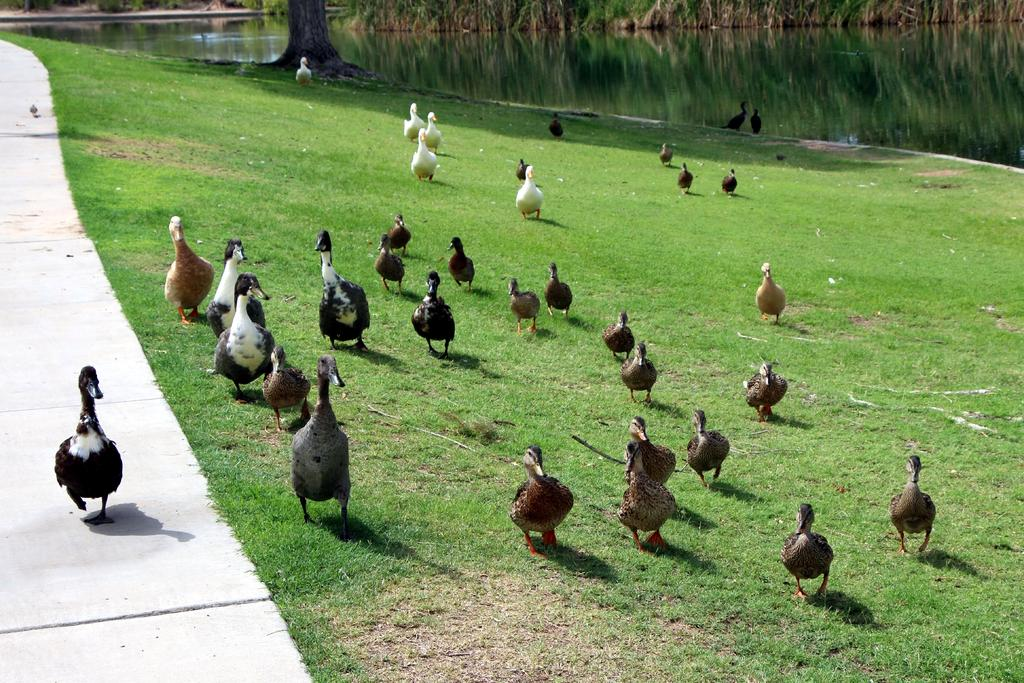What type of terrain is visible in the image? There is land with grass in the image. What animals can be seen on the land? There are many ducks on the land. What body of water is visible in the image? There is a lake behind the land. Are there any trees visible in the image? Yes, there is a tree near the lake. What type of cork is being used by the army in the image? There is no army or cork present in the image. What color is the yarn that the ducks are using to knit sweaters in the image? Ducks do not have the ability to knit sweaters or use yarn, and there is no yarn present in the image. 